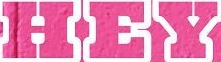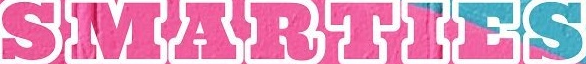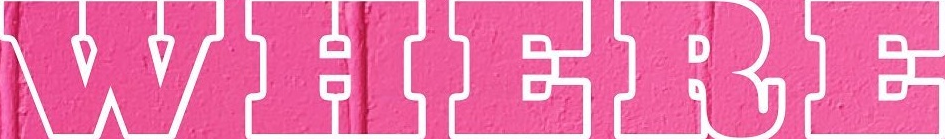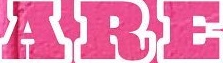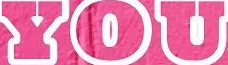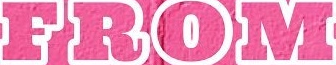What words are shown in these images in order, separated by a semicolon? HEY; SMARTIES; WHERE; ARE; YOU; FROM 